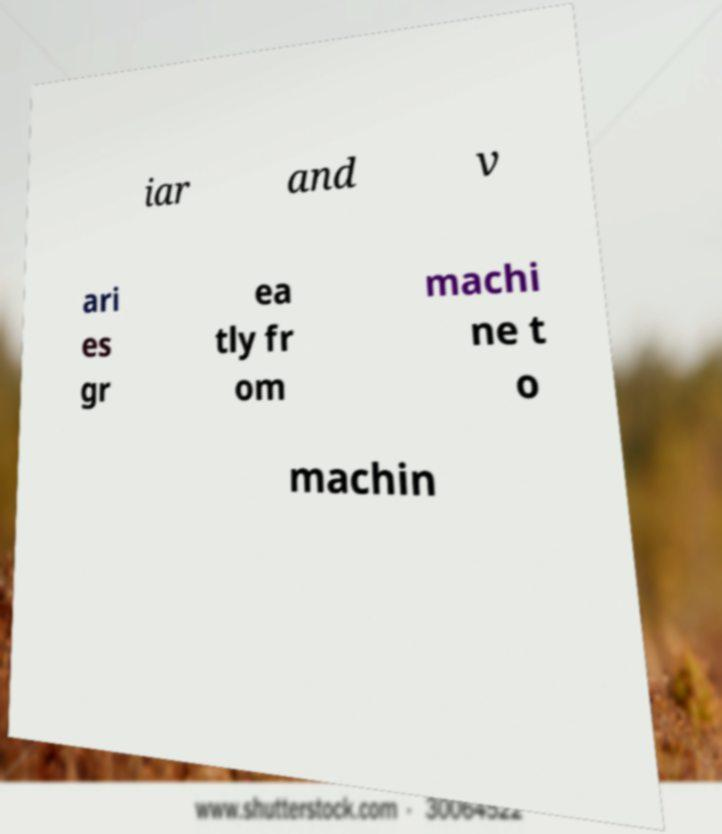For documentation purposes, I need the text within this image transcribed. Could you provide that? iar and v ari es gr ea tly fr om machi ne t o machin 